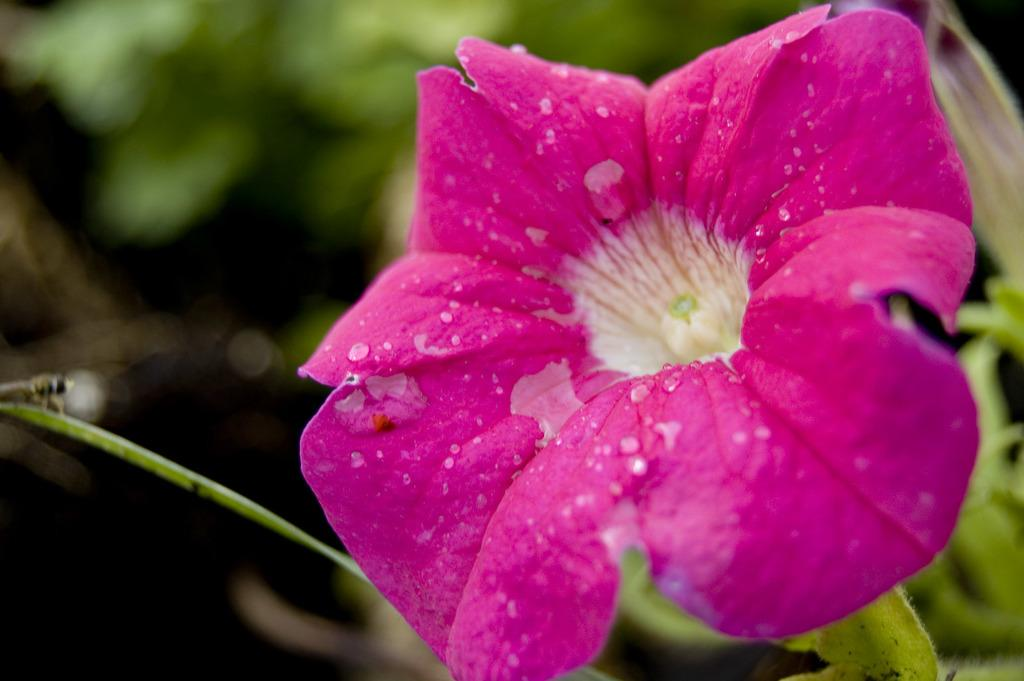What is the main subject of the image? There is a flower in the image. Where is the flower located in the image? The flower is on the right side of the image. What color is the flower? The flower is pink in color. How many toes can be seen on the flower in the image? There are no toes visible in the image, as it features a flower and flowers do not have toes. 